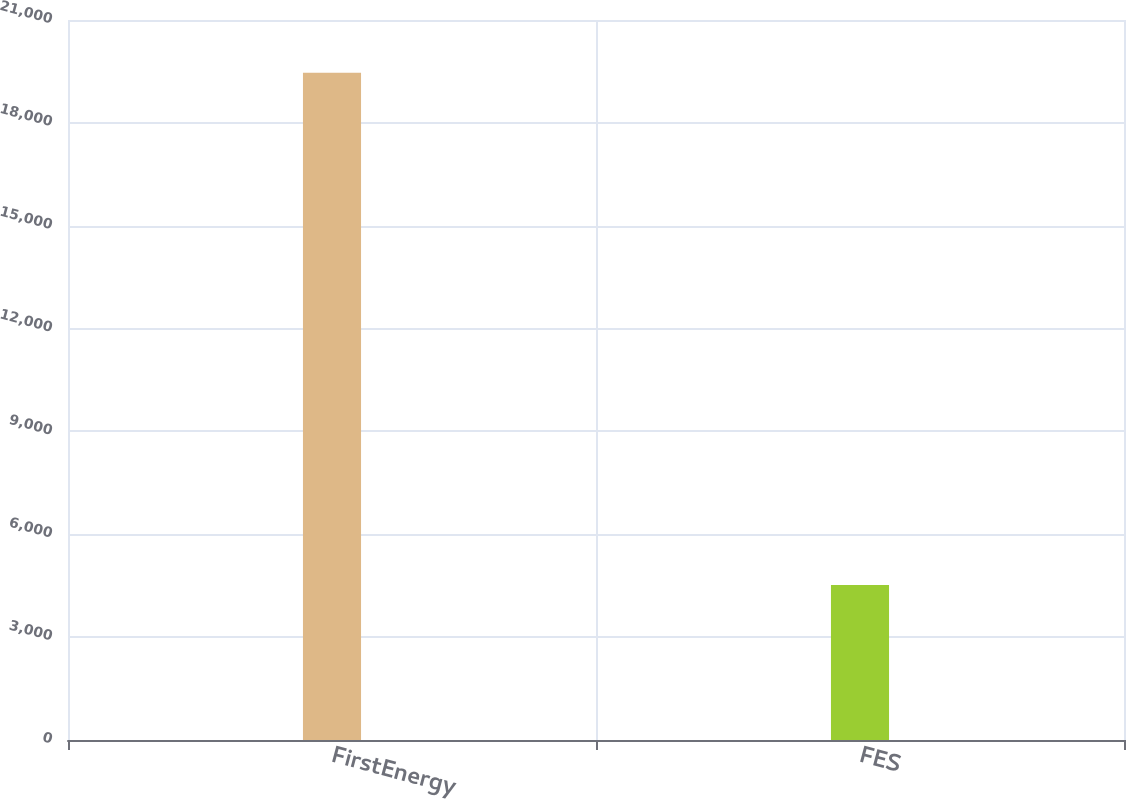Convert chart to OTSL. <chart><loc_0><loc_0><loc_500><loc_500><bar_chart><fcel>FirstEnergy<fcel>FES<nl><fcel>19460<fcel>4524<nl></chart> 